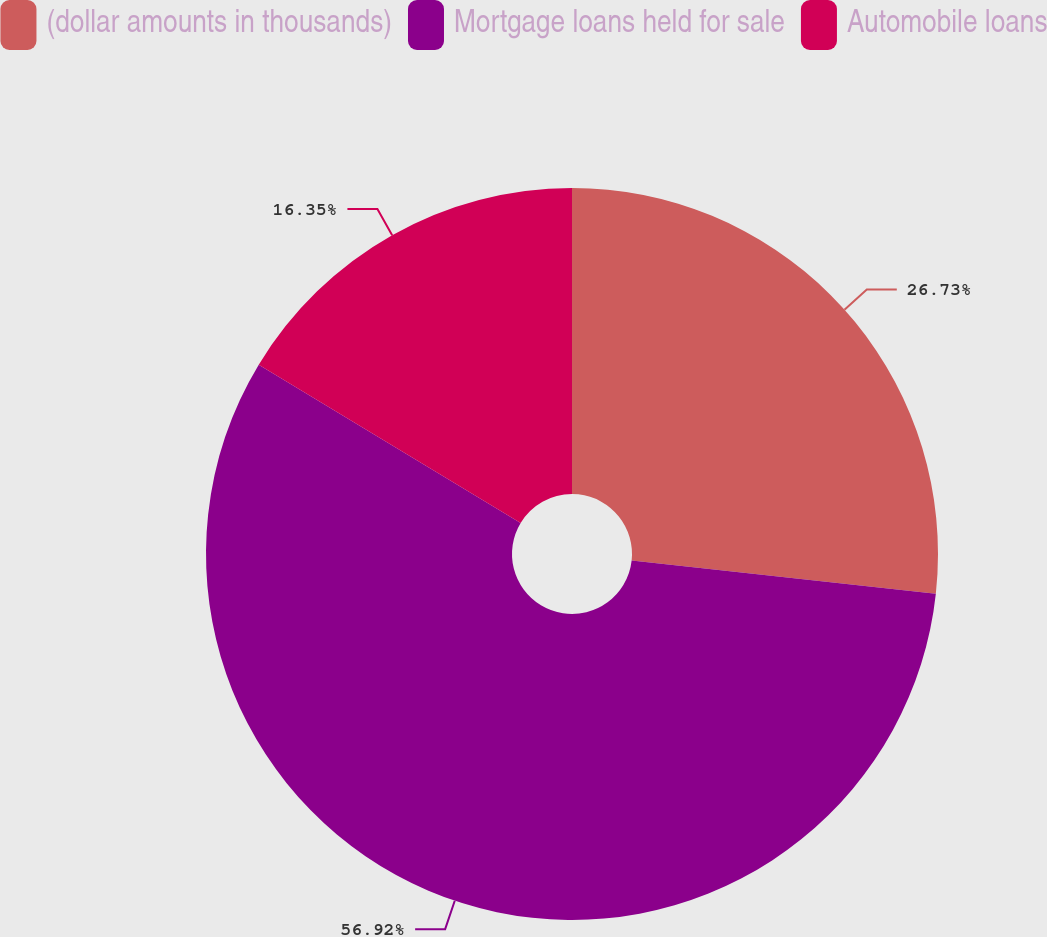<chart> <loc_0><loc_0><loc_500><loc_500><pie_chart><fcel>(dollar amounts in thousands)<fcel>Mortgage loans held for sale<fcel>Automobile loans<nl><fcel>26.73%<fcel>56.92%<fcel>16.35%<nl></chart> 